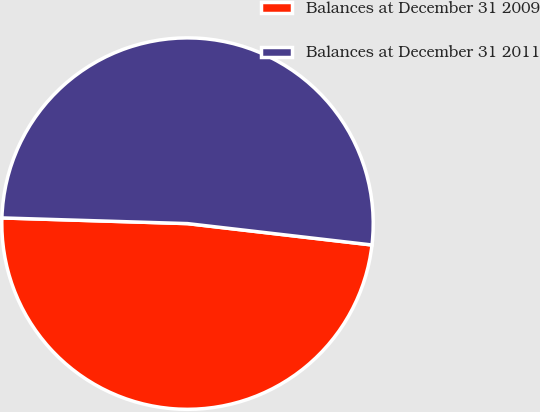Convert chart. <chart><loc_0><loc_0><loc_500><loc_500><pie_chart><fcel>Balances at December 31 2009<fcel>Balances at December 31 2011<nl><fcel>48.65%<fcel>51.35%<nl></chart> 